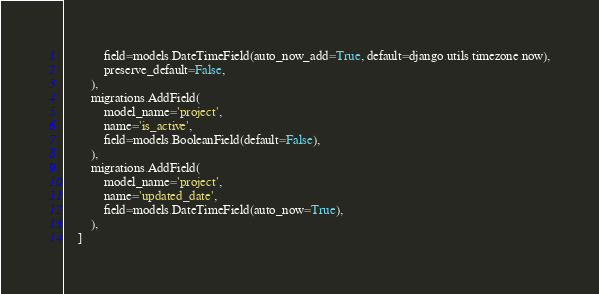<code> <loc_0><loc_0><loc_500><loc_500><_Python_>            field=models.DateTimeField(auto_now_add=True, default=django.utils.timezone.now),
            preserve_default=False,
        ),
        migrations.AddField(
            model_name='project',
            name='is_active',
            field=models.BooleanField(default=False),
        ),
        migrations.AddField(
            model_name='project',
            name='updated_date',
            field=models.DateTimeField(auto_now=True),
        ),
    ]
</code> 